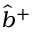<formula> <loc_0><loc_0><loc_500><loc_500>\hat { b } ^ { + }</formula> 